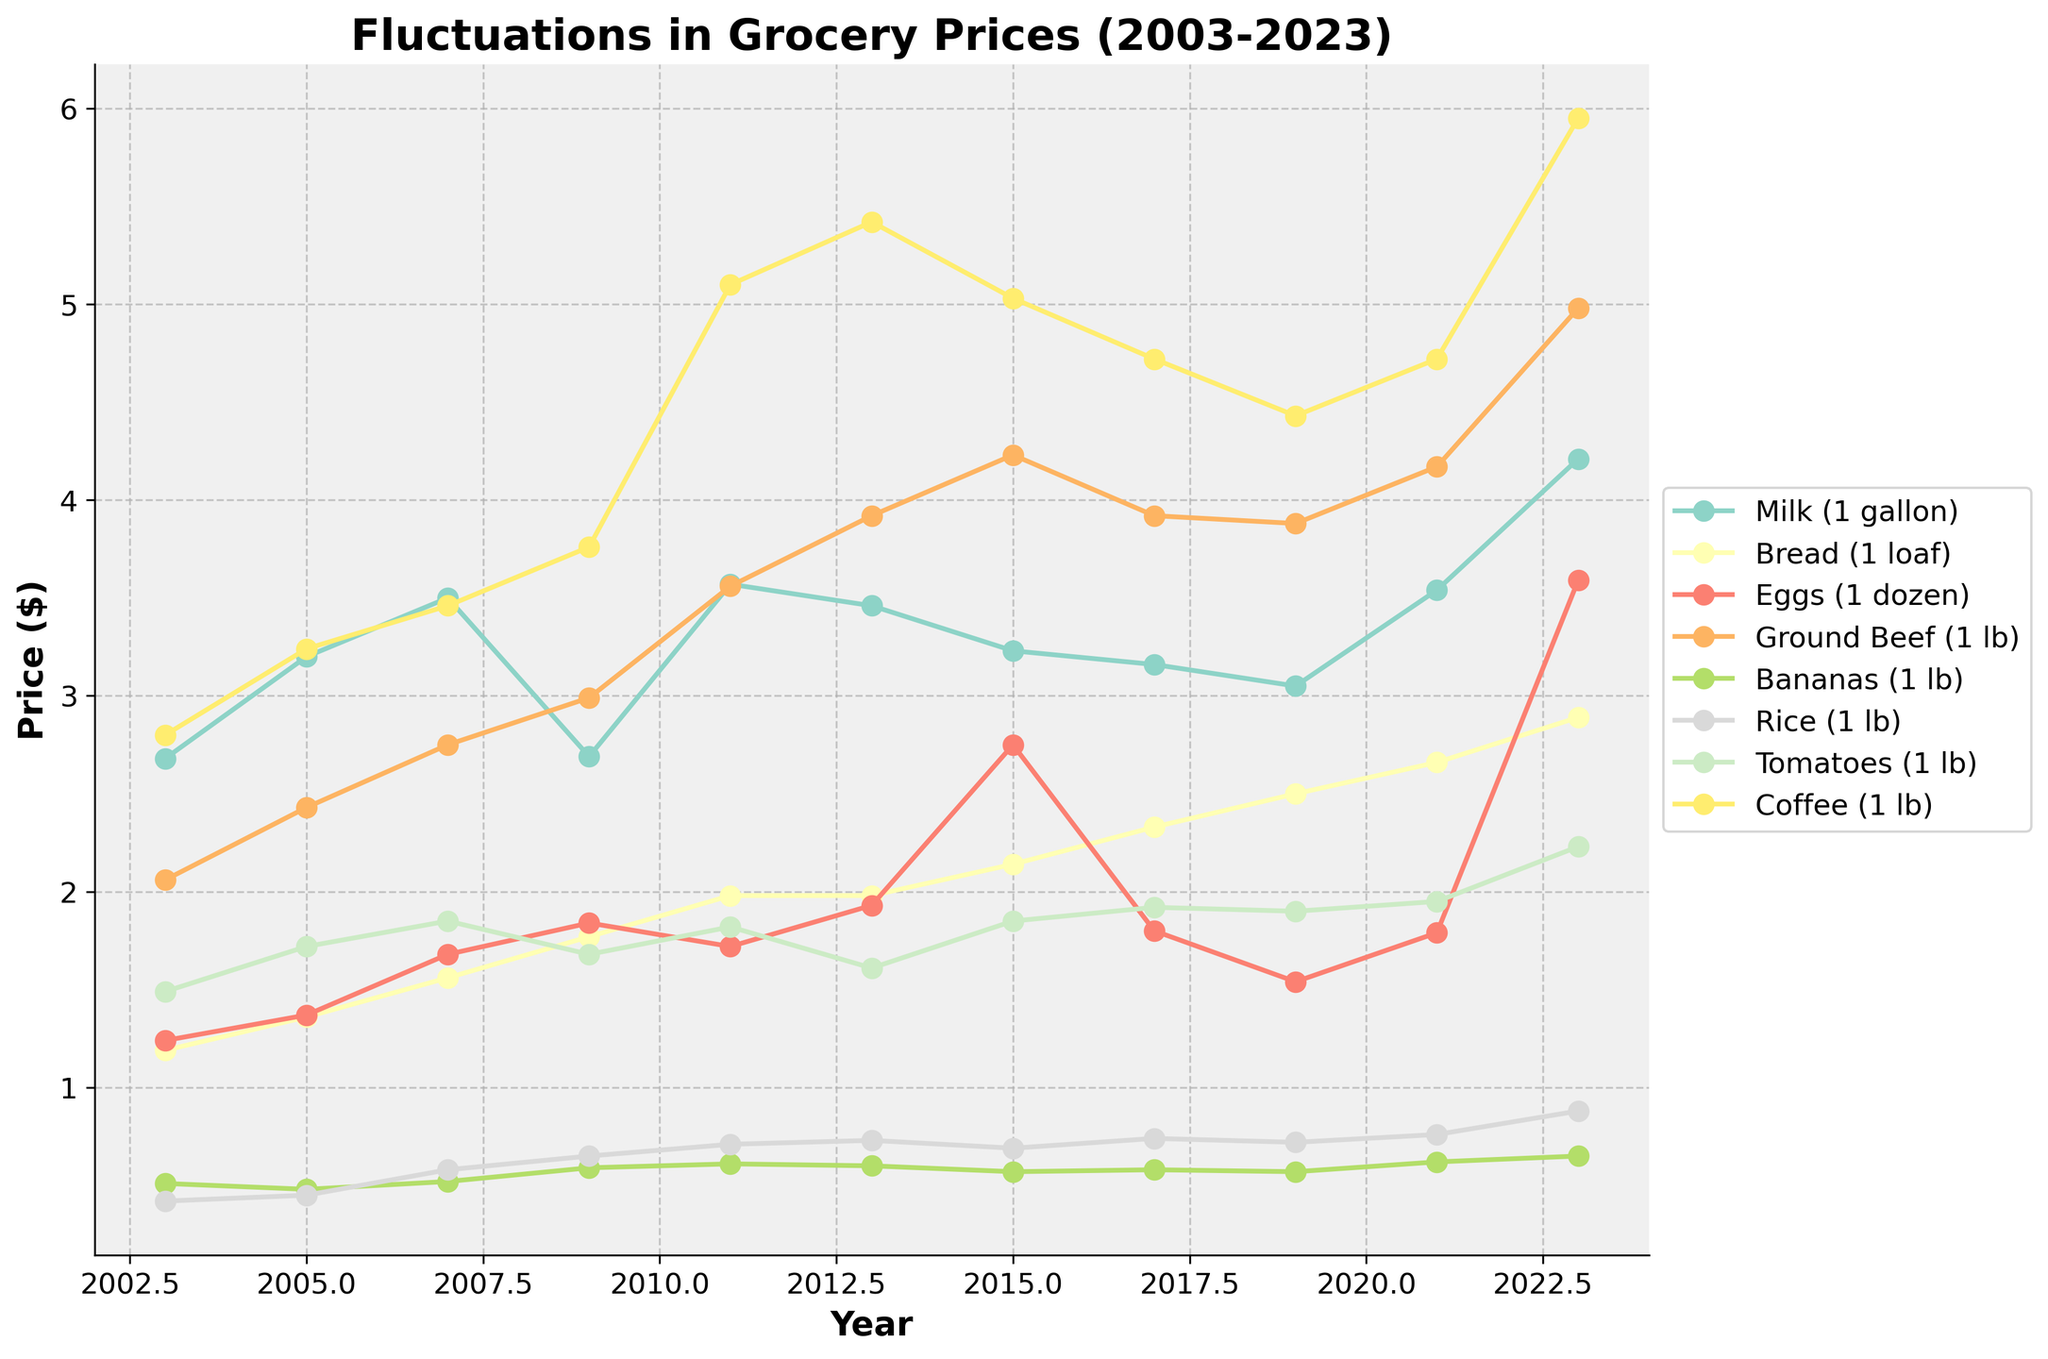What is the overall trend in the price of milk from 2003 to 2023? The graph shows the price of milk from 2003 to 2023. Starting at around $2.68 in 2003, the price fluctuated and reached $4.21 in 2023, indicating an upward trend overall.
Answer: Upward trend Which grocery item experienced the highest price increase from 2003 to 2023? Examine the starting and ending prices for each item in the graph. Comparing the differences, coffee increased from $2.80 in 2003 to $5.95 in 2023, showing the highest increase.
Answer: Coffee In which year did the price of ground beef surpass that of coffee, and what were their respective prices? Check the lines for ground beef and coffee. Ground beef surpasses coffee in 2013: ground beef at $3.92 and coffee at $5.42; coffee remains higher until after 2013.
Answer: Not applicable (Coffee is always higher than ground beef) How does the average price of a loaf of bread from 2003 to 2023 compare with the average price of a gallon of milk during the same period? Calculate the average by summing up yearly prices for bread and milk, dividing by the total number of years (11 years). The average milk price is about $3.27, and the average bread price is about $2.08.
Answer: Milk is higher When comparing eggs and tomatoes, which item had a higher price in 2011 and by how much? Check 2011 on the graph for both items. Eggs were $1.72, and tomatoes were $1.82. The difference is $1.82 - $1.72 = $0.10.
Answer: Tomatoes by $0.10 Which grocery item showed the least fluctuation in price over the two decades? Observe the lines for each item; the least fluctuation will have the most stable line. The line for bananas shows the least change, sticking close to $0.51-$0.65.
Answer: Bananas Did the price of rice increase or decrease from 2009 to 2013, and by how much? Compare the prices from 2009 ($0.65) to 2013 ($0.73). The increase is $0.73 - $0.65 = $0.08.
Answer: Increased by $0.08 Which year saw the largest increase in the price of eggs compared to the previous year shown on the graph, and what was the increase? Find the year-to-year differences for eggs. The largest jump is from 2015 to 2017, with prices going from $2.75 to $1.80. The drop is $2.75 - $1.80 = $0.95.
Answer: 2015 (but it's a decrease, not an increase) Compare the price trends of coffee and ground beef from 2003 to 2023. Which had a more consistent upward trend? Examine the lines for both items; coffee shows a more consistent upward trend, whereas ground beef has more fluctuations.
Answer: Coffee 